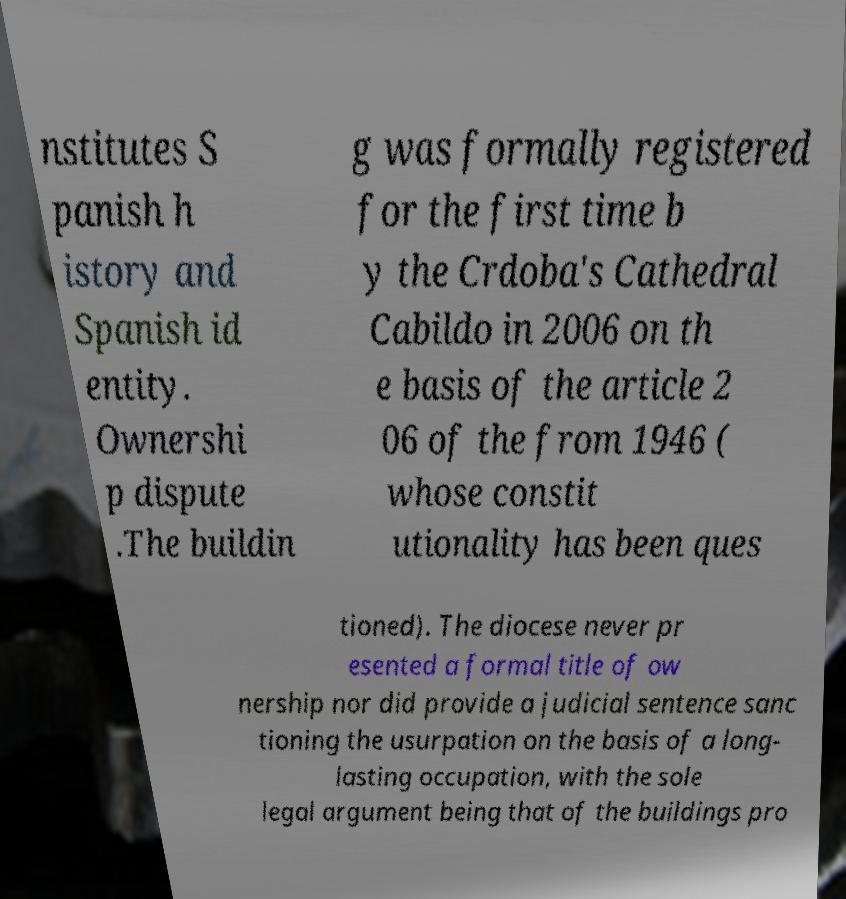For documentation purposes, I need the text within this image transcribed. Could you provide that? nstitutes S panish h istory and Spanish id entity. Ownershi p dispute .The buildin g was formally registered for the first time b y the Crdoba's Cathedral Cabildo in 2006 on th e basis of the article 2 06 of the from 1946 ( whose constit utionality has been ques tioned). The diocese never pr esented a formal title of ow nership nor did provide a judicial sentence sanc tioning the usurpation on the basis of a long- lasting occupation, with the sole legal argument being that of the buildings pro 